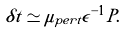Convert formula to latex. <formula><loc_0><loc_0><loc_500><loc_500>\delta t \simeq \mu _ { p e r t } \epsilon ^ { - 1 } P .</formula> 